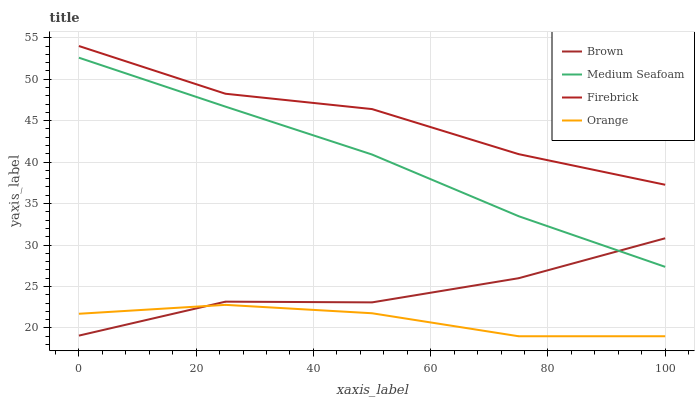Does Orange have the minimum area under the curve?
Answer yes or no. Yes. Does Firebrick have the maximum area under the curve?
Answer yes or no. Yes. Does Brown have the minimum area under the curve?
Answer yes or no. No. Does Brown have the maximum area under the curve?
Answer yes or no. No. Is Medium Seafoam the smoothest?
Answer yes or no. Yes. Is Firebrick the roughest?
Answer yes or no. Yes. Is Brown the smoothest?
Answer yes or no. No. Is Brown the roughest?
Answer yes or no. No. Does Orange have the lowest value?
Answer yes or no. Yes. Does Brown have the lowest value?
Answer yes or no. No. Does Firebrick have the highest value?
Answer yes or no. Yes. Does Brown have the highest value?
Answer yes or no. No. Is Medium Seafoam less than Firebrick?
Answer yes or no. Yes. Is Firebrick greater than Brown?
Answer yes or no. Yes. Does Orange intersect Brown?
Answer yes or no. Yes. Is Orange less than Brown?
Answer yes or no. No. Is Orange greater than Brown?
Answer yes or no. No. Does Medium Seafoam intersect Firebrick?
Answer yes or no. No. 